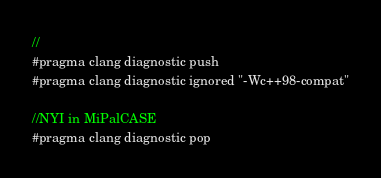<code> <loc_0><loc_0><loc_500><loc_500><_ObjectiveC_>//
#pragma clang diagnostic push
#pragma clang diagnostic ignored "-Wc++98-compat"

//NYI in MiPalCASE
#pragma clang diagnostic pop
</code> 